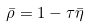Convert formula to latex. <formula><loc_0><loc_0><loc_500><loc_500>\bar { \rho } = 1 - \tau \bar { \eta }</formula> 